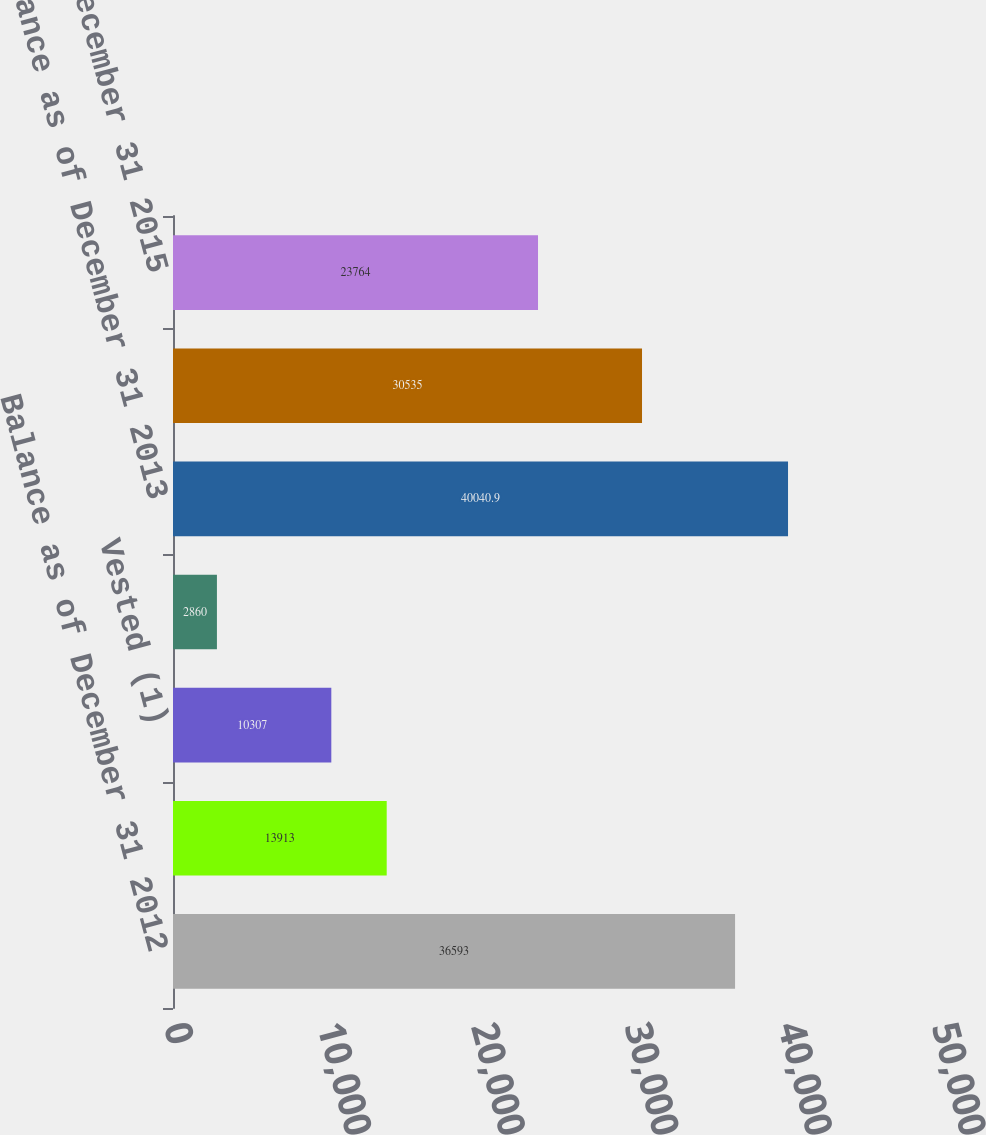<chart> <loc_0><loc_0><loc_500><loc_500><bar_chart><fcel>Balance as of December 31 2012<fcel>Granted<fcel>Vested (1)<fcel>Forfeited<fcel>Balance as of December 31 2013<fcel>Balance as of December 31 2014<fcel>Balance as of December 31 2015<nl><fcel>36593<fcel>13913<fcel>10307<fcel>2860<fcel>40040.9<fcel>30535<fcel>23764<nl></chart> 